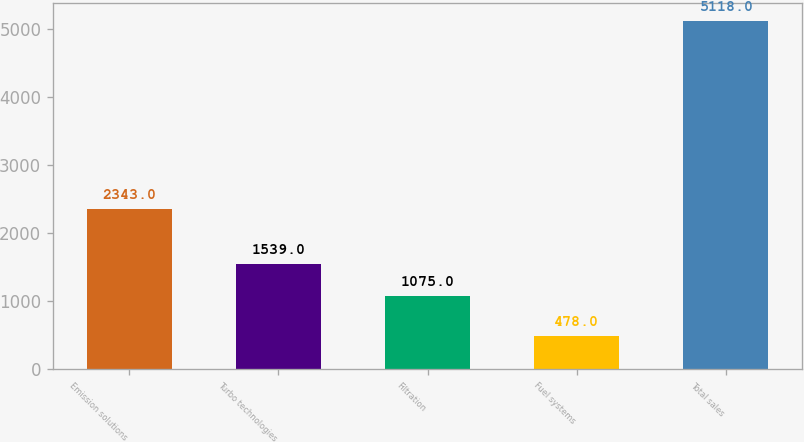<chart> <loc_0><loc_0><loc_500><loc_500><bar_chart><fcel>Emission solutions<fcel>Turbo technologies<fcel>Filtration<fcel>Fuel systems<fcel>Total sales<nl><fcel>2343<fcel>1539<fcel>1075<fcel>478<fcel>5118<nl></chart> 